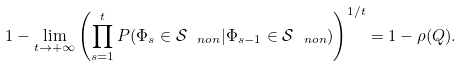Convert formula to latex. <formula><loc_0><loc_0><loc_500><loc_500>1 - \lim _ { t \to + \infty } \left ( \prod ^ { t } _ { s = 1 } P ( \Phi _ { s } \in \mathcal { S } _ { \ n o n } | \Phi _ { s - 1 } \in \mathcal { S } _ { \ n o n } ) \right ) ^ { 1 / t } = 1 - \rho ( Q ) .</formula> 